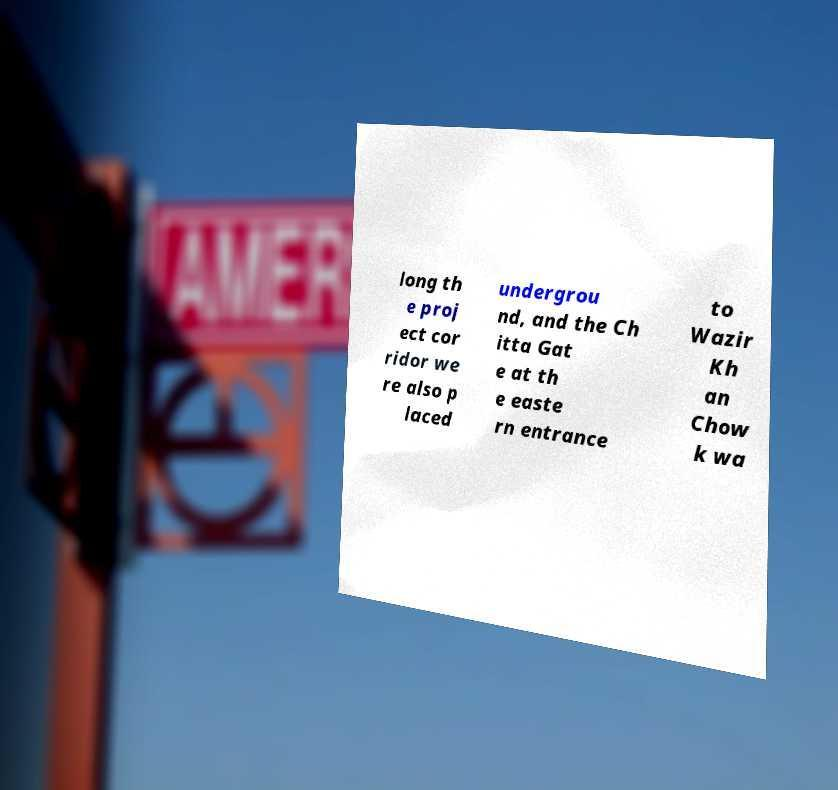What messages or text are displayed in this image? I need them in a readable, typed format. long th e proj ect cor ridor we re also p laced undergrou nd, and the Ch itta Gat e at th e easte rn entrance to Wazir Kh an Chow k wa 